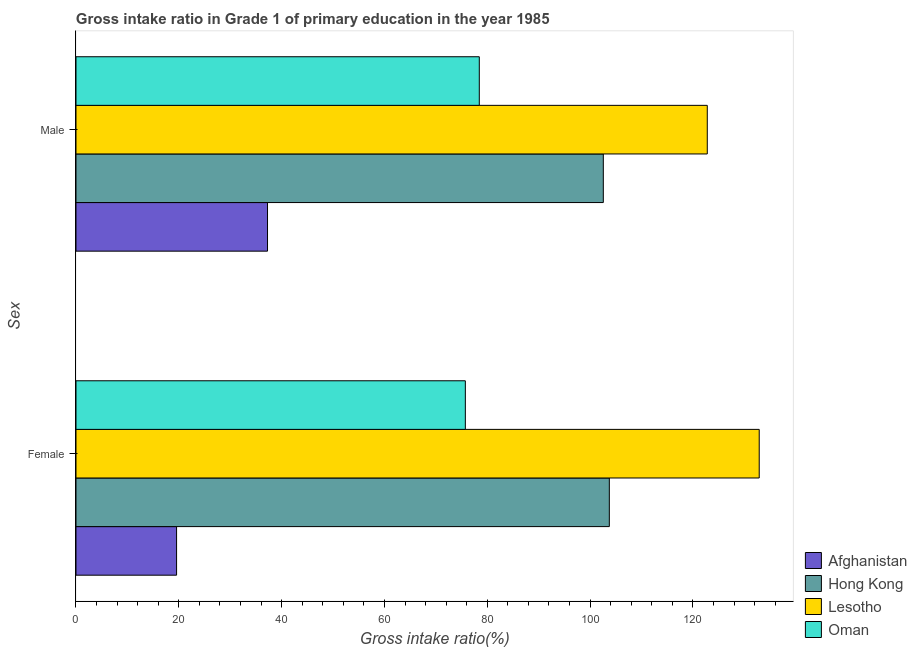How many groups of bars are there?
Your answer should be very brief. 2. How many bars are there on the 1st tick from the top?
Keep it short and to the point. 4. How many bars are there on the 1st tick from the bottom?
Ensure brevity in your answer.  4. What is the gross intake ratio(male) in Oman?
Provide a short and direct response. 78.45. Across all countries, what is the maximum gross intake ratio(male)?
Your response must be concise. 122.8. Across all countries, what is the minimum gross intake ratio(male)?
Make the answer very short. 37.26. In which country was the gross intake ratio(male) maximum?
Your response must be concise. Lesotho. In which country was the gross intake ratio(male) minimum?
Provide a succinct answer. Afghanistan. What is the total gross intake ratio(male) in the graph?
Ensure brevity in your answer.  341.08. What is the difference between the gross intake ratio(female) in Hong Kong and that in Lesotho?
Your answer should be compact. -29.16. What is the difference between the gross intake ratio(male) in Afghanistan and the gross intake ratio(female) in Oman?
Offer a very short reply. -38.48. What is the average gross intake ratio(female) per country?
Offer a terse response. 82.99. What is the difference between the gross intake ratio(female) and gross intake ratio(male) in Hong Kong?
Your answer should be very brief. 1.17. What is the ratio of the gross intake ratio(male) in Afghanistan to that in Lesotho?
Keep it short and to the point. 0.3. What does the 1st bar from the top in Male represents?
Offer a terse response. Oman. What does the 4th bar from the bottom in Female represents?
Make the answer very short. Oman. Are all the bars in the graph horizontal?
Give a very brief answer. Yes. How many countries are there in the graph?
Provide a succinct answer. 4. Are the values on the major ticks of X-axis written in scientific E-notation?
Ensure brevity in your answer.  No. Does the graph contain grids?
Your answer should be compact. No. How many legend labels are there?
Ensure brevity in your answer.  4. What is the title of the graph?
Your answer should be compact. Gross intake ratio in Grade 1 of primary education in the year 1985. What is the label or title of the X-axis?
Your answer should be very brief. Gross intake ratio(%). What is the label or title of the Y-axis?
Give a very brief answer. Sex. What is the Gross intake ratio(%) in Afghanistan in Female?
Your answer should be compact. 19.57. What is the Gross intake ratio(%) of Hong Kong in Female?
Provide a short and direct response. 103.75. What is the Gross intake ratio(%) of Lesotho in Female?
Ensure brevity in your answer.  132.9. What is the Gross intake ratio(%) in Oman in Female?
Provide a short and direct response. 75.74. What is the Gross intake ratio(%) of Afghanistan in Male?
Your answer should be very brief. 37.26. What is the Gross intake ratio(%) of Hong Kong in Male?
Your answer should be very brief. 102.57. What is the Gross intake ratio(%) of Lesotho in Male?
Ensure brevity in your answer.  122.8. What is the Gross intake ratio(%) of Oman in Male?
Offer a very short reply. 78.45. Across all Sex, what is the maximum Gross intake ratio(%) of Afghanistan?
Give a very brief answer. 37.26. Across all Sex, what is the maximum Gross intake ratio(%) in Hong Kong?
Provide a succinct answer. 103.75. Across all Sex, what is the maximum Gross intake ratio(%) of Lesotho?
Your response must be concise. 132.9. Across all Sex, what is the maximum Gross intake ratio(%) of Oman?
Your answer should be compact. 78.45. Across all Sex, what is the minimum Gross intake ratio(%) of Afghanistan?
Make the answer very short. 19.57. Across all Sex, what is the minimum Gross intake ratio(%) in Hong Kong?
Your answer should be very brief. 102.57. Across all Sex, what is the minimum Gross intake ratio(%) of Lesotho?
Offer a terse response. 122.8. Across all Sex, what is the minimum Gross intake ratio(%) of Oman?
Your response must be concise. 75.74. What is the total Gross intake ratio(%) of Afghanistan in the graph?
Offer a terse response. 56.82. What is the total Gross intake ratio(%) of Hong Kong in the graph?
Ensure brevity in your answer.  206.32. What is the total Gross intake ratio(%) of Lesotho in the graph?
Your answer should be very brief. 255.7. What is the total Gross intake ratio(%) of Oman in the graph?
Offer a very short reply. 154.19. What is the difference between the Gross intake ratio(%) of Afghanistan in Female and that in Male?
Make the answer very short. -17.69. What is the difference between the Gross intake ratio(%) in Hong Kong in Female and that in Male?
Ensure brevity in your answer.  1.17. What is the difference between the Gross intake ratio(%) of Lesotho in Female and that in Male?
Your answer should be very brief. 10.1. What is the difference between the Gross intake ratio(%) of Oman in Female and that in Male?
Offer a terse response. -2.71. What is the difference between the Gross intake ratio(%) in Afghanistan in Female and the Gross intake ratio(%) in Hong Kong in Male?
Provide a succinct answer. -83.01. What is the difference between the Gross intake ratio(%) of Afghanistan in Female and the Gross intake ratio(%) of Lesotho in Male?
Offer a very short reply. -103.23. What is the difference between the Gross intake ratio(%) of Afghanistan in Female and the Gross intake ratio(%) of Oman in Male?
Your answer should be very brief. -58.88. What is the difference between the Gross intake ratio(%) of Hong Kong in Female and the Gross intake ratio(%) of Lesotho in Male?
Offer a very short reply. -19.06. What is the difference between the Gross intake ratio(%) in Hong Kong in Female and the Gross intake ratio(%) in Oman in Male?
Give a very brief answer. 25.29. What is the difference between the Gross intake ratio(%) in Lesotho in Female and the Gross intake ratio(%) in Oman in Male?
Offer a terse response. 54.45. What is the average Gross intake ratio(%) in Afghanistan per Sex?
Keep it short and to the point. 28.41. What is the average Gross intake ratio(%) of Hong Kong per Sex?
Make the answer very short. 103.16. What is the average Gross intake ratio(%) in Lesotho per Sex?
Make the answer very short. 127.85. What is the average Gross intake ratio(%) of Oman per Sex?
Give a very brief answer. 77.09. What is the difference between the Gross intake ratio(%) in Afghanistan and Gross intake ratio(%) in Hong Kong in Female?
Your answer should be compact. -84.18. What is the difference between the Gross intake ratio(%) in Afghanistan and Gross intake ratio(%) in Lesotho in Female?
Your answer should be very brief. -113.34. What is the difference between the Gross intake ratio(%) in Afghanistan and Gross intake ratio(%) in Oman in Female?
Your answer should be compact. -56.17. What is the difference between the Gross intake ratio(%) of Hong Kong and Gross intake ratio(%) of Lesotho in Female?
Your answer should be compact. -29.16. What is the difference between the Gross intake ratio(%) of Hong Kong and Gross intake ratio(%) of Oman in Female?
Keep it short and to the point. 28.01. What is the difference between the Gross intake ratio(%) of Lesotho and Gross intake ratio(%) of Oman in Female?
Make the answer very short. 57.17. What is the difference between the Gross intake ratio(%) in Afghanistan and Gross intake ratio(%) in Hong Kong in Male?
Provide a succinct answer. -65.32. What is the difference between the Gross intake ratio(%) of Afghanistan and Gross intake ratio(%) of Lesotho in Male?
Offer a very short reply. -85.54. What is the difference between the Gross intake ratio(%) in Afghanistan and Gross intake ratio(%) in Oman in Male?
Your answer should be very brief. -41.19. What is the difference between the Gross intake ratio(%) of Hong Kong and Gross intake ratio(%) of Lesotho in Male?
Make the answer very short. -20.23. What is the difference between the Gross intake ratio(%) in Hong Kong and Gross intake ratio(%) in Oman in Male?
Your response must be concise. 24.12. What is the difference between the Gross intake ratio(%) of Lesotho and Gross intake ratio(%) of Oman in Male?
Offer a terse response. 44.35. What is the ratio of the Gross intake ratio(%) in Afghanistan in Female to that in Male?
Your answer should be compact. 0.53. What is the ratio of the Gross intake ratio(%) in Hong Kong in Female to that in Male?
Make the answer very short. 1.01. What is the ratio of the Gross intake ratio(%) in Lesotho in Female to that in Male?
Provide a succinct answer. 1.08. What is the ratio of the Gross intake ratio(%) in Oman in Female to that in Male?
Offer a very short reply. 0.97. What is the difference between the highest and the second highest Gross intake ratio(%) in Afghanistan?
Make the answer very short. 17.69. What is the difference between the highest and the second highest Gross intake ratio(%) of Hong Kong?
Your response must be concise. 1.17. What is the difference between the highest and the second highest Gross intake ratio(%) in Lesotho?
Provide a succinct answer. 10.1. What is the difference between the highest and the second highest Gross intake ratio(%) in Oman?
Your response must be concise. 2.71. What is the difference between the highest and the lowest Gross intake ratio(%) in Afghanistan?
Your response must be concise. 17.69. What is the difference between the highest and the lowest Gross intake ratio(%) of Hong Kong?
Your response must be concise. 1.17. What is the difference between the highest and the lowest Gross intake ratio(%) of Lesotho?
Make the answer very short. 10.1. What is the difference between the highest and the lowest Gross intake ratio(%) in Oman?
Offer a terse response. 2.71. 